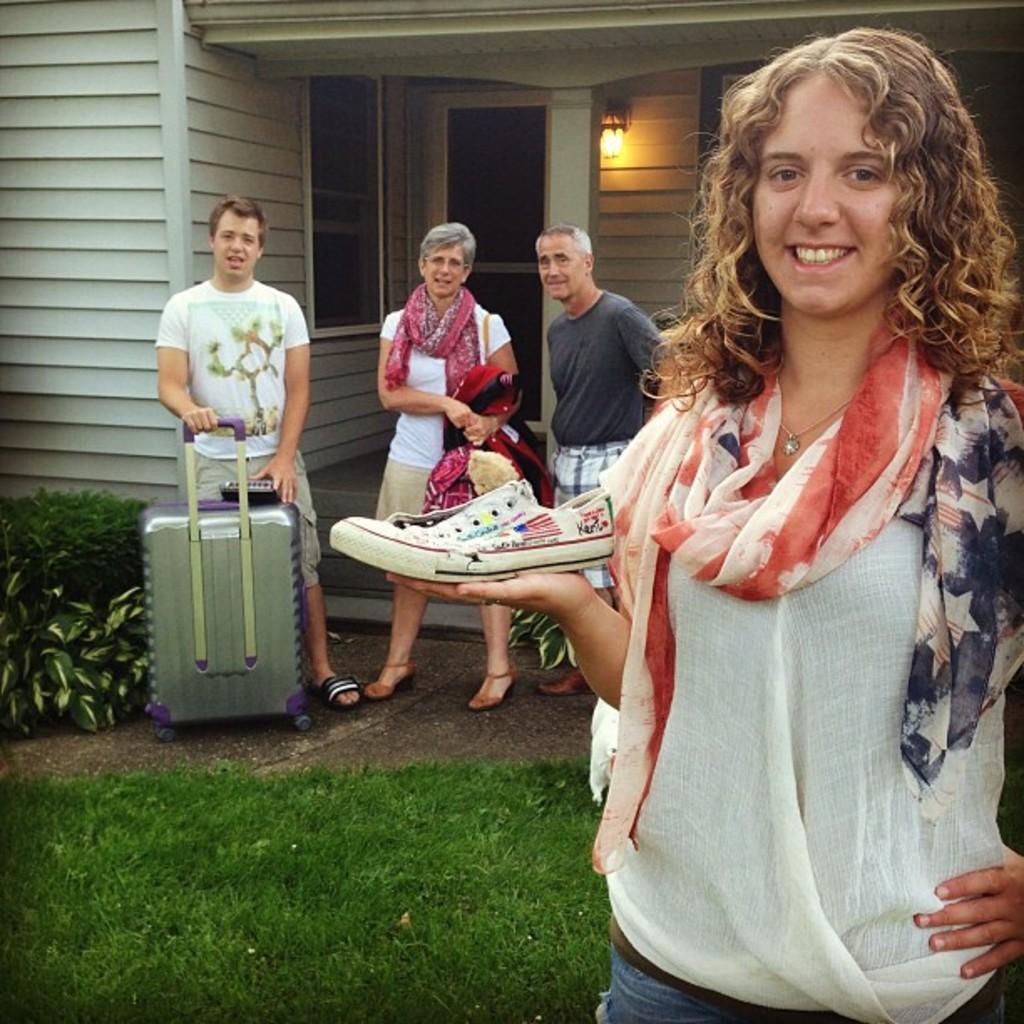Could you give a brief overview of what you see in this image? in this picture a woman is standing she is smiling, she is wearing a scarf, and she is holding a shoe in her hand. here it is a grass on floor, and here it is a building with light and doors ,and man is standing with a travelling bag, and here is a woman she wearing a glasses ,and here is a man standing. 